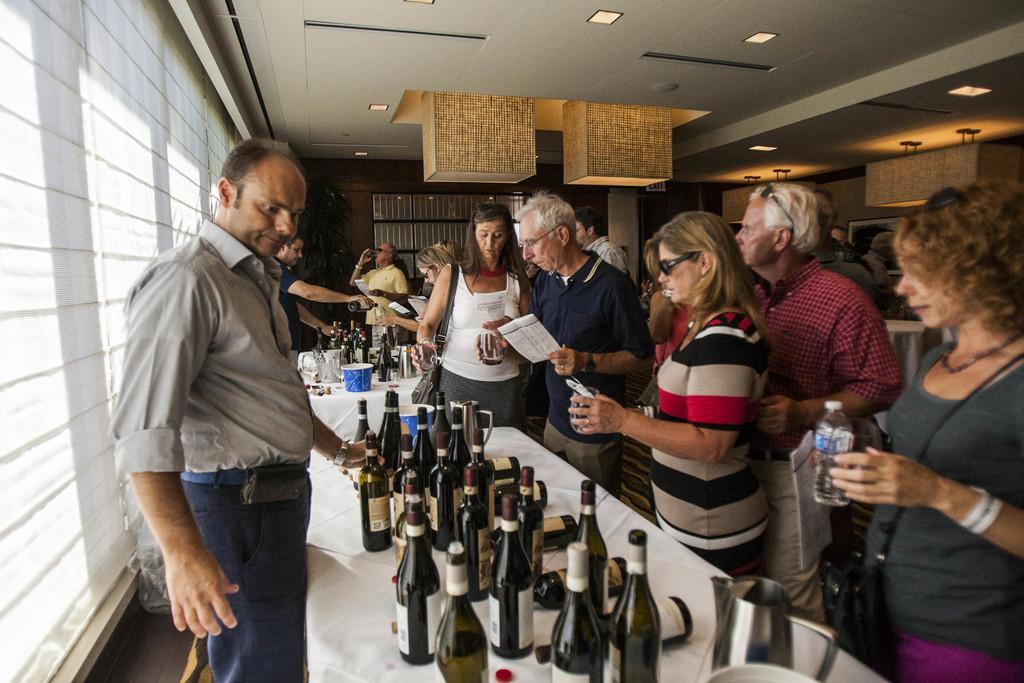Could you give a brief overview of what you see in this image? In this image we can see a group of people standing near a table containing some bottles, jar, a bowl and some glasses. We can also see some people holding the bottles, glasses and papers. On the backside we can see a wall, ceiling lights and a roof. 